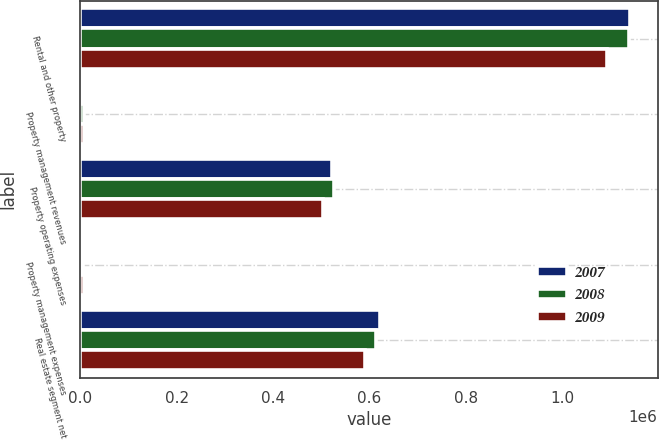Convert chart to OTSL. <chart><loc_0><loc_0><loc_500><loc_500><stacked_bar_chart><ecel><fcel>Rental and other property<fcel>Property management revenues<fcel>Property operating expenses<fcel>Property management expenses<fcel>Real estate segment net<nl><fcel>2007<fcel>1.14083e+06<fcel>5082<fcel>521161<fcel>2869<fcel>621880<nl><fcel>2008<fcel>1.138e+06<fcel>6345<fcel>526238<fcel>5385<fcel>612717<nl><fcel>2009<fcel>1.09378e+06<fcel>6923<fcel>503890<fcel>6678<fcel>590134<nl></chart> 